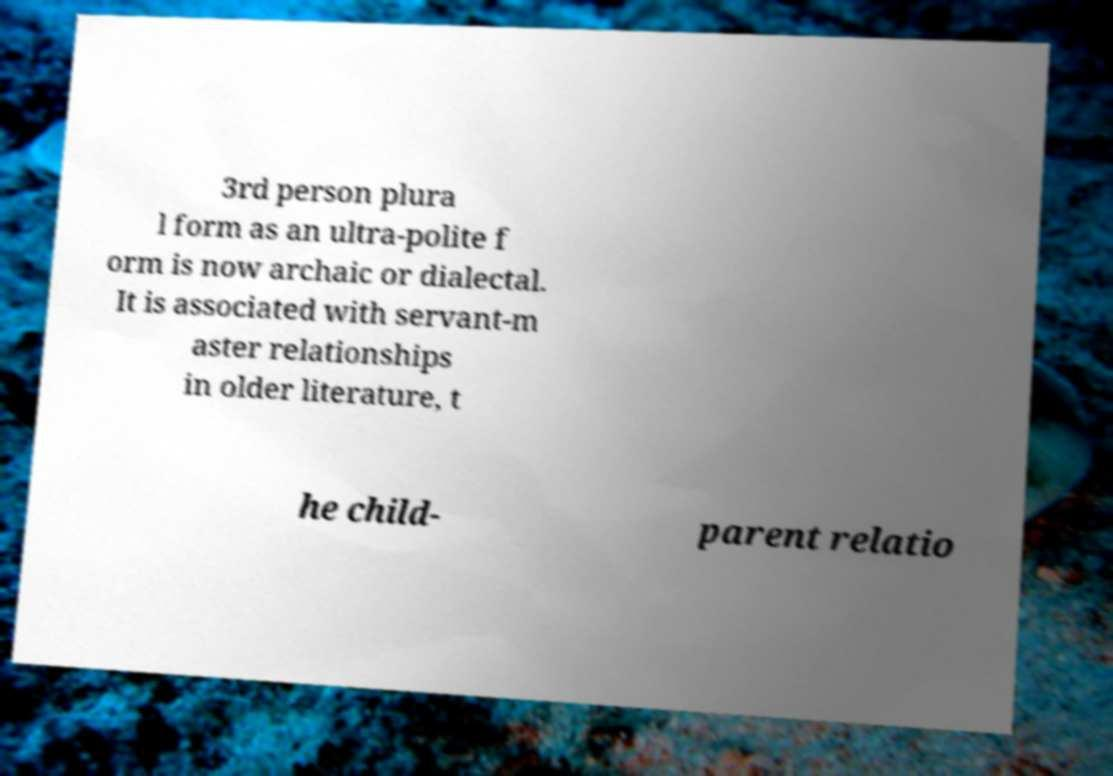Could you extract and type out the text from this image? 3rd person plura l form as an ultra-polite f orm is now archaic or dialectal. It is associated with servant-m aster relationships in older literature, t he child- parent relatio 